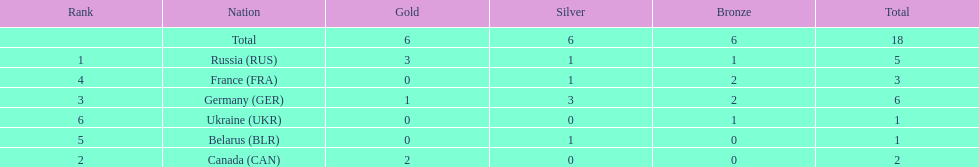How many silver medals did belarus win? 1. Give me the full table as a dictionary. {'header': ['Rank', 'Nation', 'Gold', 'Silver', 'Bronze', 'Total'], 'rows': [['', 'Total', '6', '6', '6', '18'], ['1', 'Russia\xa0(RUS)', '3', '1', '1', '5'], ['4', 'France\xa0(FRA)', '0', '1', '2', '3'], ['3', 'Germany\xa0(GER)', '1', '3', '2', '6'], ['6', 'Ukraine\xa0(UKR)', '0', '0', '1', '1'], ['5', 'Belarus\xa0(BLR)', '0', '1', '0', '1'], ['2', 'Canada\xa0(CAN)', '2', '0', '0', '2']]} 